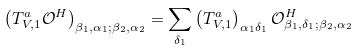<formula> <loc_0><loc_0><loc_500><loc_500>\left ( T ^ { a } _ { V , 1 } \mathcal { O } ^ { H } \right ) _ { \beta _ { 1 } , \alpha _ { 1 } ; \beta _ { 2 } , \alpha _ { 2 } } = \sum _ { \delta _ { 1 } } \left ( T ^ { a } _ { V , 1 } \right ) _ { \alpha _ { 1 } \delta _ { 1 } } \mathcal { O } ^ { H } _ { \beta _ { 1 } , \delta _ { 1 } ; \beta _ { 2 } , \alpha _ { 2 } }</formula> 